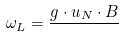Convert formula to latex. <formula><loc_0><loc_0><loc_500><loc_500>\omega _ { L } = { \frac { g \cdot u _ { N } \cdot B } { } }</formula> 